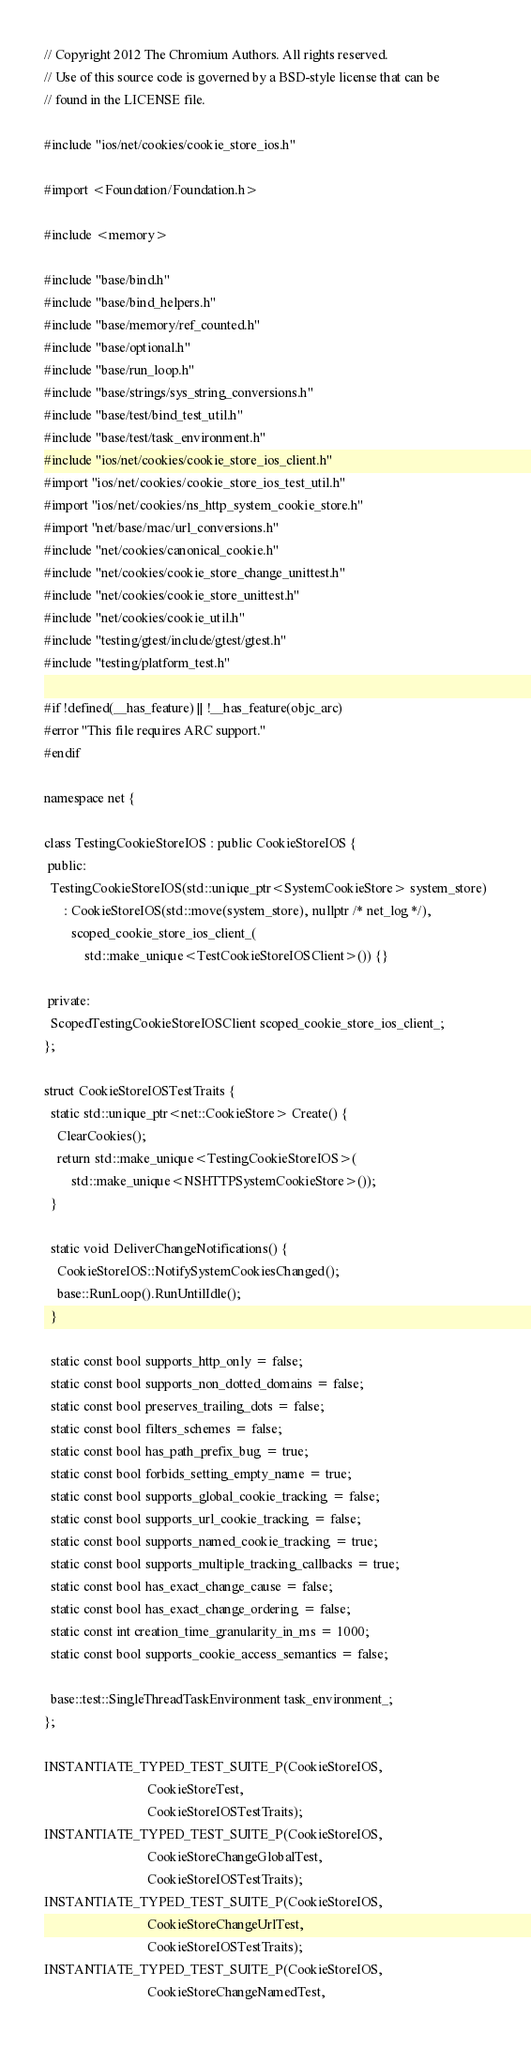<code> <loc_0><loc_0><loc_500><loc_500><_ObjectiveC_>// Copyright 2012 The Chromium Authors. All rights reserved.
// Use of this source code is governed by a BSD-style license that can be
// found in the LICENSE file.

#include "ios/net/cookies/cookie_store_ios.h"

#import <Foundation/Foundation.h>

#include <memory>

#include "base/bind.h"
#include "base/bind_helpers.h"
#include "base/memory/ref_counted.h"
#include "base/optional.h"
#include "base/run_loop.h"
#include "base/strings/sys_string_conversions.h"
#include "base/test/bind_test_util.h"
#include "base/test/task_environment.h"
#include "ios/net/cookies/cookie_store_ios_client.h"
#import "ios/net/cookies/cookie_store_ios_test_util.h"
#import "ios/net/cookies/ns_http_system_cookie_store.h"
#import "net/base/mac/url_conversions.h"
#include "net/cookies/canonical_cookie.h"
#include "net/cookies/cookie_store_change_unittest.h"
#include "net/cookies/cookie_store_unittest.h"
#include "net/cookies/cookie_util.h"
#include "testing/gtest/include/gtest/gtest.h"
#include "testing/platform_test.h"

#if !defined(__has_feature) || !__has_feature(objc_arc)
#error "This file requires ARC support."
#endif

namespace net {

class TestingCookieStoreIOS : public CookieStoreIOS {
 public:
  TestingCookieStoreIOS(std::unique_ptr<SystemCookieStore> system_store)
      : CookieStoreIOS(std::move(system_store), nullptr /* net_log */),
        scoped_cookie_store_ios_client_(
            std::make_unique<TestCookieStoreIOSClient>()) {}

 private:
  ScopedTestingCookieStoreIOSClient scoped_cookie_store_ios_client_;
};

struct CookieStoreIOSTestTraits {
  static std::unique_ptr<net::CookieStore> Create() {
    ClearCookies();
    return std::make_unique<TestingCookieStoreIOS>(
        std::make_unique<NSHTTPSystemCookieStore>());
  }

  static void DeliverChangeNotifications() {
    CookieStoreIOS::NotifySystemCookiesChanged();
    base::RunLoop().RunUntilIdle();
  }

  static const bool supports_http_only = false;
  static const bool supports_non_dotted_domains = false;
  static const bool preserves_trailing_dots = false;
  static const bool filters_schemes = false;
  static const bool has_path_prefix_bug = true;
  static const bool forbids_setting_empty_name = true;
  static const bool supports_global_cookie_tracking = false;
  static const bool supports_url_cookie_tracking = false;
  static const bool supports_named_cookie_tracking = true;
  static const bool supports_multiple_tracking_callbacks = true;
  static const bool has_exact_change_cause = false;
  static const bool has_exact_change_ordering = false;
  static const int creation_time_granularity_in_ms = 1000;
  static const bool supports_cookie_access_semantics = false;

  base::test::SingleThreadTaskEnvironment task_environment_;
};

INSTANTIATE_TYPED_TEST_SUITE_P(CookieStoreIOS,
                               CookieStoreTest,
                               CookieStoreIOSTestTraits);
INSTANTIATE_TYPED_TEST_SUITE_P(CookieStoreIOS,
                               CookieStoreChangeGlobalTest,
                               CookieStoreIOSTestTraits);
INSTANTIATE_TYPED_TEST_SUITE_P(CookieStoreIOS,
                               CookieStoreChangeUrlTest,
                               CookieStoreIOSTestTraits);
INSTANTIATE_TYPED_TEST_SUITE_P(CookieStoreIOS,
                               CookieStoreChangeNamedTest,</code> 